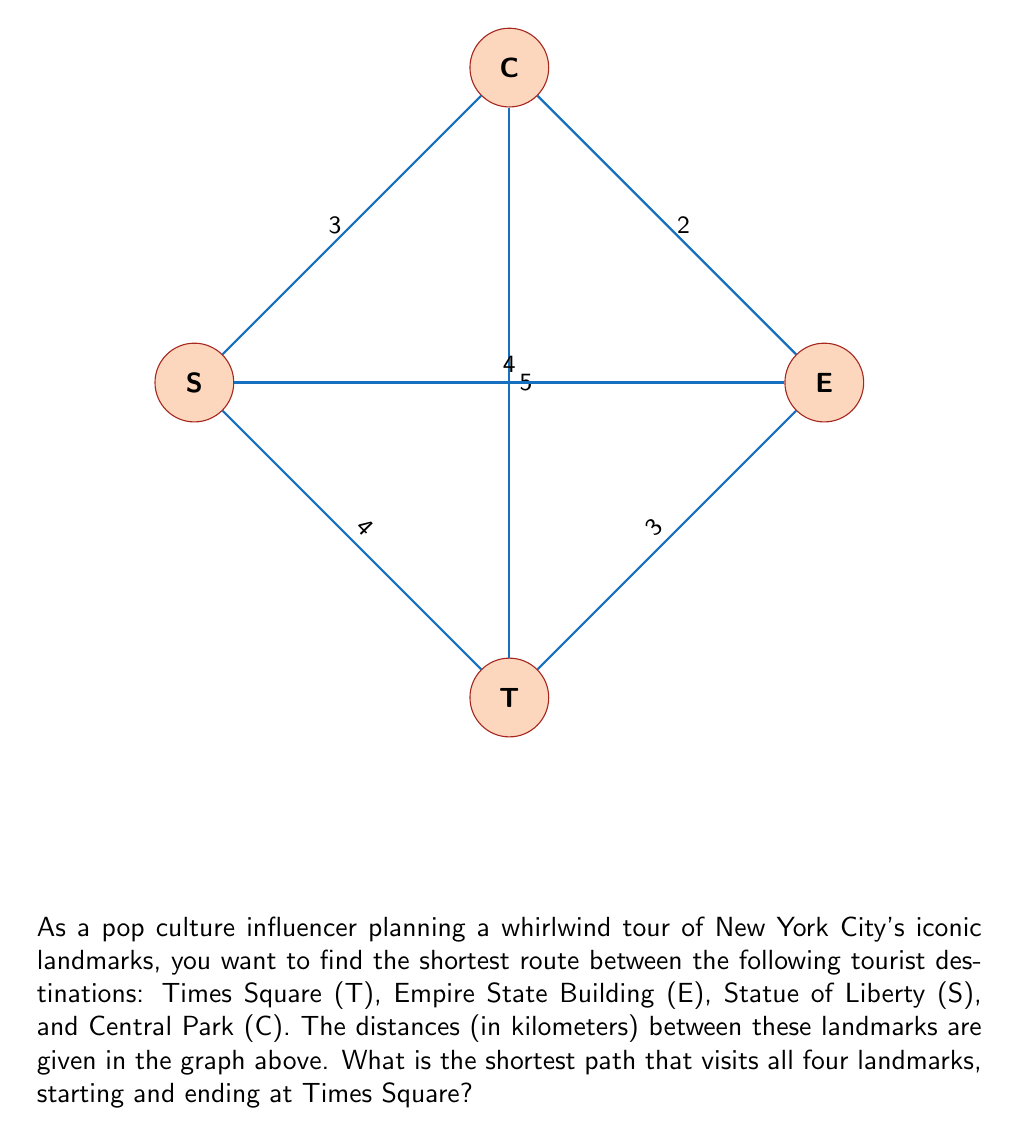Solve this math problem. To solve this problem, we'll use Dijkstra's algorithm to find the shortest path that visits all landmarks and returns to the starting point. This is known as the Traveling Salesman Problem.

Step 1: List all possible routes starting and ending at Times Square (T) that visit all landmarks.
- T → E → S → C → T
- T → E → C → S → T
- T → S → E → C → T
- T → S → C → E → T
- T → C → E → S → T
- T → C → S → E → T

Step 2: Calculate the total distance for each route.
1. T → E → S → C → T = 3 + 4 + 3 + 5 = 15 km
2. T → E → C → S → T = 3 + 2 + 3 + 4 = 12 km
3. T → S → E → C → T = 4 + 4 + 2 + 5 = 15 km
4. T → S → C → E → T = 4 + 3 + 2 + 3 = 12 km
5. T → C → E → S → T = 5 + 2 + 4 + 4 = 15 km
6. T → C → S → E → T = 5 + 3 + 4 + 3 = 15 km

Step 3: Identify the shortest path(s).
The shortest paths are:
- T → E → C → S → T (12 km)
- T → S → C → E → T (12 km)

Both paths have the same total distance, so either can be chosen as the optimal route.
Answer: T → E → C → S → T or T → S → C → E → T (12 km) 